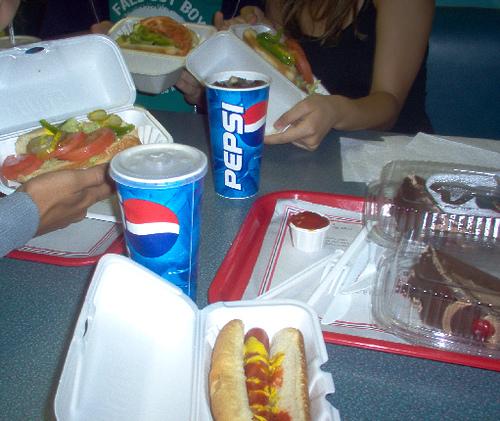How many hot dogs are seen?
Be succinct. 1. What is in the cup?
Answer briefly. Pepsi. Do the people like fast food?
Keep it brief. Yes. What color is the cake?
Short answer required. Brown. How many types of fondue are available?
Short answer required. 0. What type of bar is this?
Concise answer only. Sports. What is the color of food tray?
Write a very short answer. Red. 